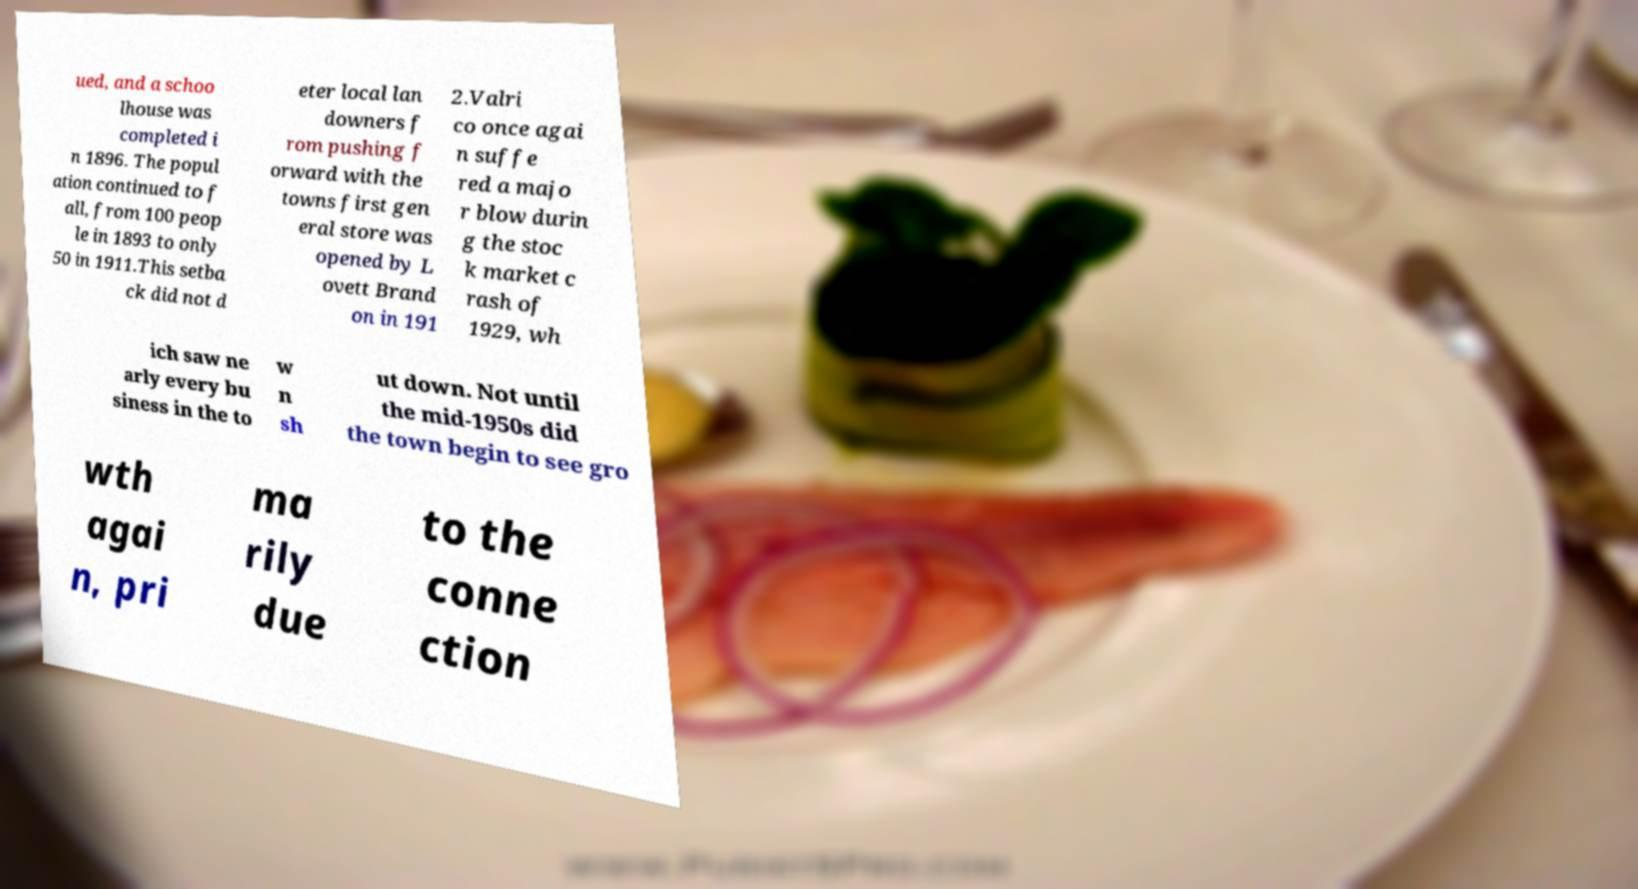Please read and relay the text visible in this image. What does it say? ued, and a schoo lhouse was completed i n 1896. The popul ation continued to f all, from 100 peop le in 1893 to only 50 in 1911.This setba ck did not d eter local lan downers f rom pushing f orward with the towns first gen eral store was opened by L ovett Brand on in 191 2.Valri co once agai n suffe red a majo r blow durin g the stoc k market c rash of 1929, wh ich saw ne arly every bu siness in the to w n sh ut down. Not until the mid-1950s did the town begin to see gro wth agai n, pri ma rily due to the conne ction 